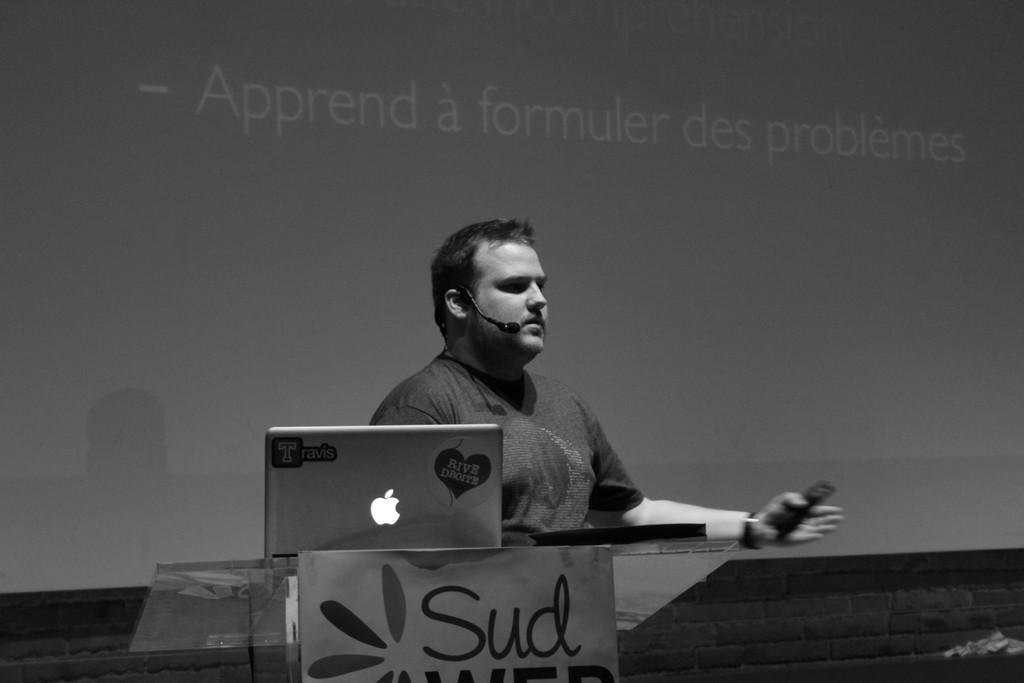Can you describe this image briefly? In this picture we can see a person talking, he is holding an object in hands, in front we can see laptop, some objects are placed on the table, behind we can see display on the board. 